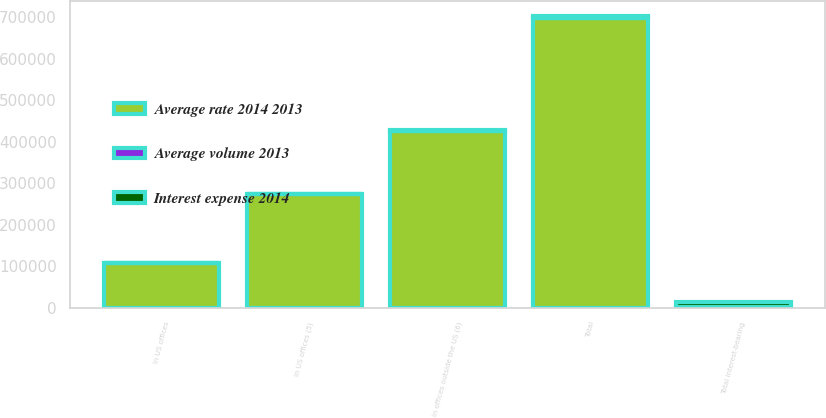Convert chart to OTSL. <chart><loc_0><loc_0><loc_500><loc_500><stacked_bar_chart><ecel><fcel>In US offices (5)<fcel>In offices outside the US (6)<fcel>Total<fcel>In US offices<fcel>Total interest-bearing<nl><fcel>Average rate 2014 2013<fcel>273122<fcel>425053<fcel>698175<fcel>108286<fcel>2526<nl><fcel>Interest expense 2014<fcel>1291<fcel>3761<fcel>5052<fcel>721<fcel>11921<nl><fcel>Average volume 2013<fcel>0.47<fcel>0.88<fcel>0.72<fcel>0.67<fcel>0.95<nl></chart> 